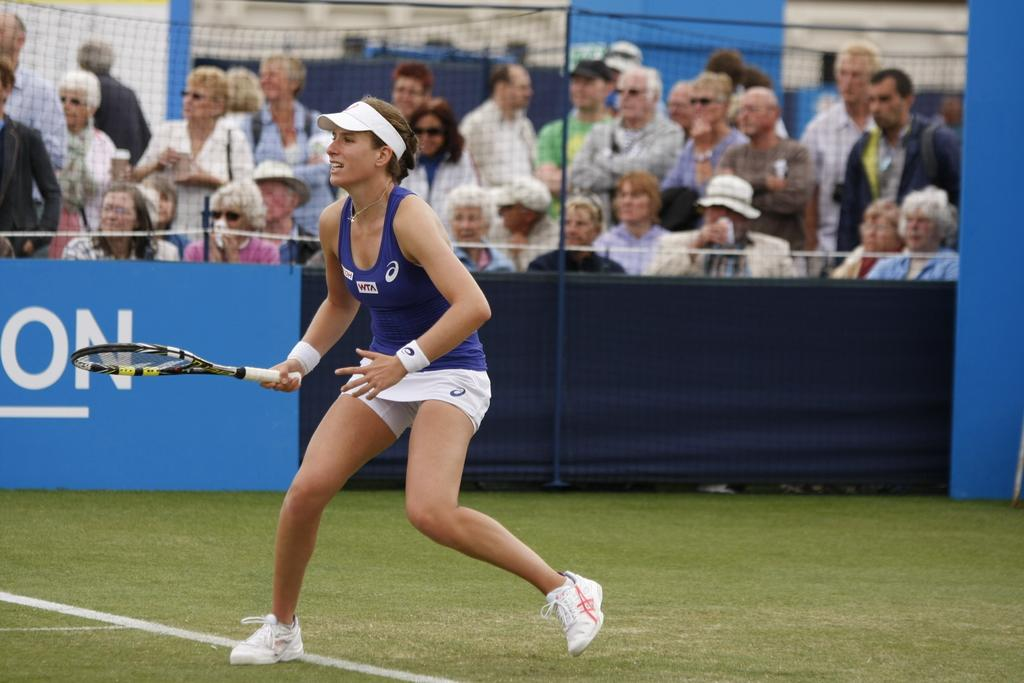How many people are in the image? There are people in the image, but the exact number is not specified. Can you describe the woman in the image? A woman is standing in the image. What is the woman holding in the image? The woman is holding a shuttle bat in the image. What type of brush is the woman using to paint the room in the image? There is no brush or room present in the image; the woman is holding a shuttle bat. 